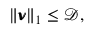<formula> <loc_0><loc_0><loc_500><loc_500>\begin{array} { r } { \| \pm b { \nu } \| _ { 1 } \leq \mathcal { D } , } \end{array}</formula> 